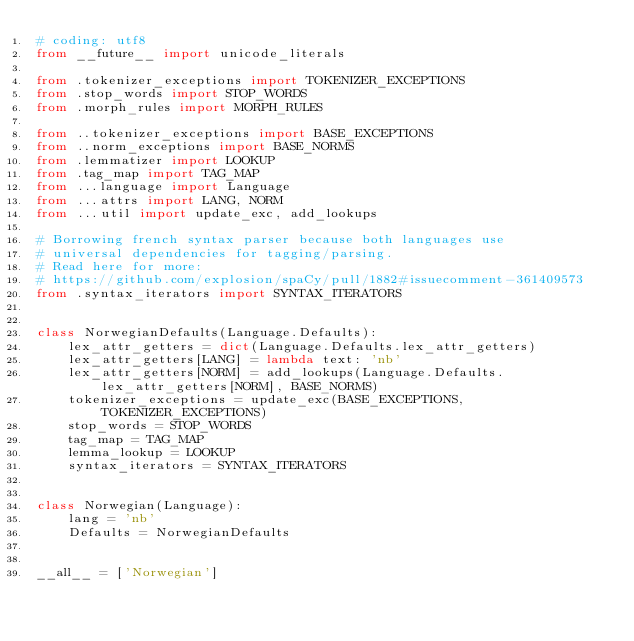<code> <loc_0><loc_0><loc_500><loc_500><_Python_># coding: utf8
from __future__ import unicode_literals

from .tokenizer_exceptions import TOKENIZER_EXCEPTIONS
from .stop_words import STOP_WORDS
from .morph_rules import MORPH_RULES

from ..tokenizer_exceptions import BASE_EXCEPTIONS
from ..norm_exceptions import BASE_NORMS
from .lemmatizer import LOOKUP
from .tag_map import TAG_MAP
from ...language import Language
from ...attrs import LANG, NORM
from ...util import update_exc, add_lookups

# Borrowing french syntax parser because both languages use
# universal dependencies for tagging/parsing.
# Read here for more:
# https://github.com/explosion/spaCy/pull/1882#issuecomment-361409573
from .syntax_iterators import SYNTAX_ITERATORS


class NorwegianDefaults(Language.Defaults):
    lex_attr_getters = dict(Language.Defaults.lex_attr_getters)
    lex_attr_getters[LANG] = lambda text: 'nb'
    lex_attr_getters[NORM] = add_lookups(Language.Defaults.lex_attr_getters[NORM], BASE_NORMS)
    tokenizer_exceptions = update_exc(BASE_EXCEPTIONS, TOKENIZER_EXCEPTIONS)
    stop_words = STOP_WORDS
    tag_map = TAG_MAP
    lemma_lookup = LOOKUP
    syntax_iterators = SYNTAX_ITERATORS


class Norwegian(Language):
    lang = 'nb'
    Defaults = NorwegianDefaults


__all__ = ['Norwegian']
</code> 